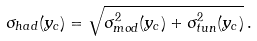Convert formula to latex. <formula><loc_0><loc_0><loc_500><loc_500>\sigma _ { h a d } ( y _ { c } ) = \sqrt { \sigma _ { m o d } ^ { 2 } ( y _ { c } ) + \sigma _ { t u n } ^ { 2 } ( y _ { c } ) } \, .</formula> 